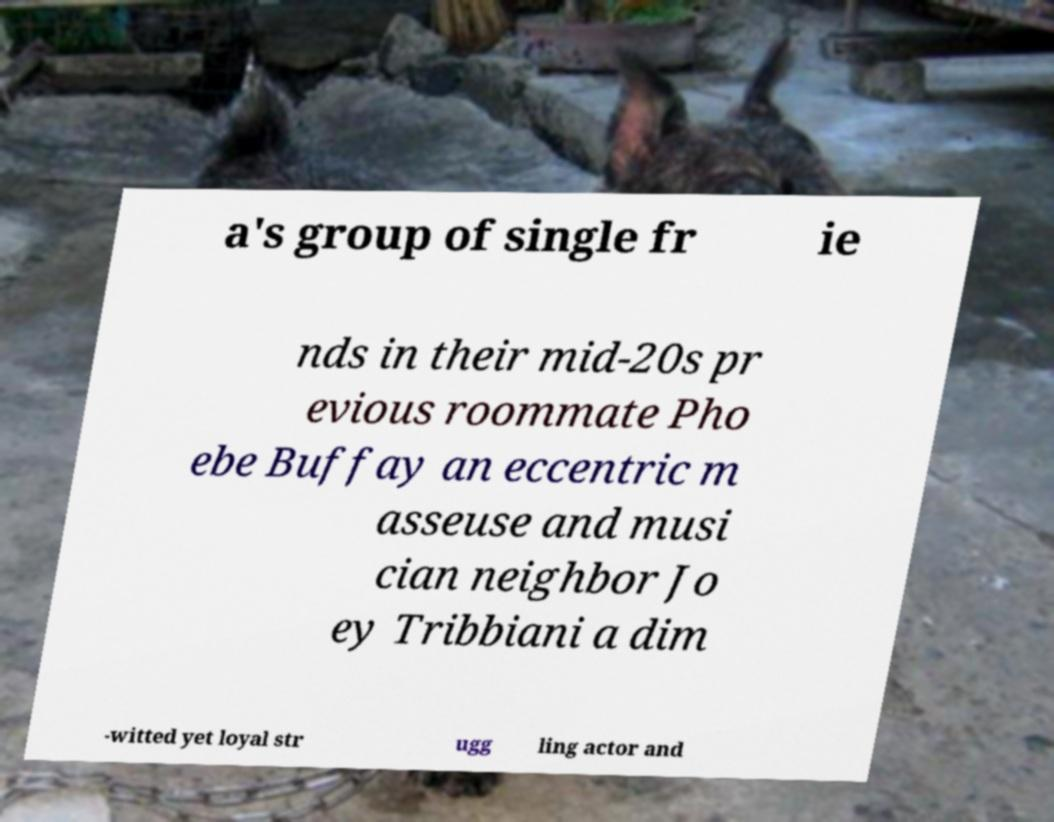Please read and relay the text visible in this image. What does it say? a's group of single fr ie nds in their mid-20s pr evious roommate Pho ebe Buffay an eccentric m asseuse and musi cian neighbor Jo ey Tribbiani a dim -witted yet loyal str ugg ling actor and 